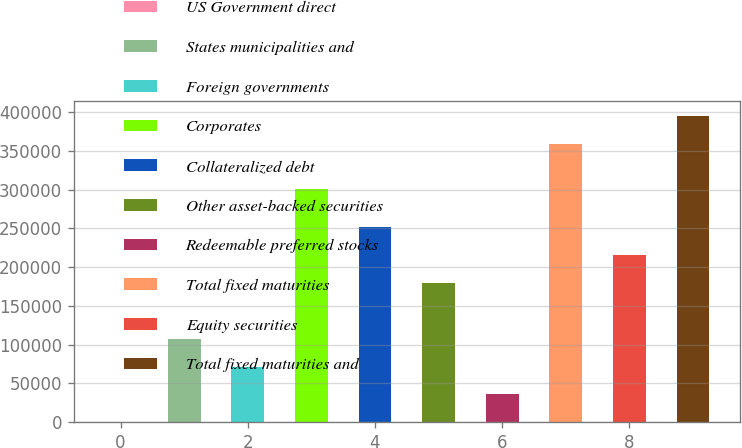Convert chart to OTSL. <chart><loc_0><loc_0><loc_500><loc_500><bar_chart><fcel>US Government direct<fcel>States municipalities and<fcel>Foreign governments<fcel>Corporates<fcel>Collateralized debt<fcel>Other asset-backed securities<fcel>Redeemable preferred stocks<fcel>Total fixed maturities<fcel>Equity securities<fcel>Total fixed maturities and<nl><fcel>1.28<fcel>107785<fcel>71857.2<fcel>300300<fcel>251497<fcel>179641<fcel>35929.2<fcel>358505<fcel>215569<fcel>394433<nl></chart> 